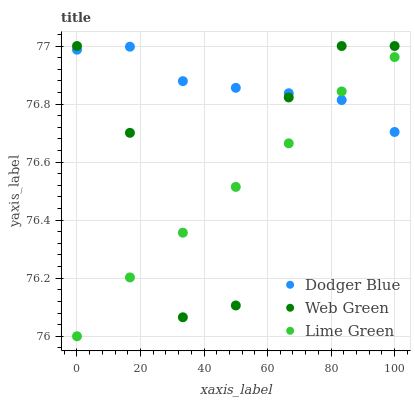Does Lime Green have the minimum area under the curve?
Answer yes or no. Yes. Does Dodger Blue have the maximum area under the curve?
Answer yes or no. Yes. Does Web Green have the minimum area under the curve?
Answer yes or no. No. Does Web Green have the maximum area under the curve?
Answer yes or no. No. Is Lime Green the smoothest?
Answer yes or no. Yes. Is Web Green the roughest?
Answer yes or no. Yes. Is Dodger Blue the smoothest?
Answer yes or no. No. Is Dodger Blue the roughest?
Answer yes or no. No. Does Lime Green have the lowest value?
Answer yes or no. Yes. Does Web Green have the lowest value?
Answer yes or no. No. Does Web Green have the highest value?
Answer yes or no. Yes. Does Dodger Blue have the highest value?
Answer yes or no. No. Does Web Green intersect Dodger Blue?
Answer yes or no. Yes. Is Web Green less than Dodger Blue?
Answer yes or no. No. Is Web Green greater than Dodger Blue?
Answer yes or no. No. 